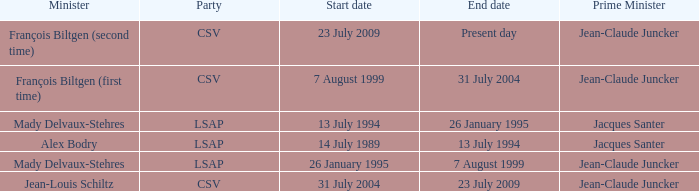What was the end date when Alex Bodry was the minister? 13 July 1994. 